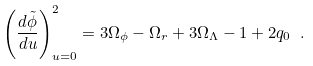Convert formula to latex. <formula><loc_0><loc_0><loc_500><loc_500>\left ( \frac { d \tilde { \phi } } { d u } \right ) ^ { 2 } _ { u = 0 } = 3 \Omega _ { \phi } - \Omega _ { r } + 3 \Omega _ { \Lambda } - 1 + 2 q _ { 0 } \ .</formula> 